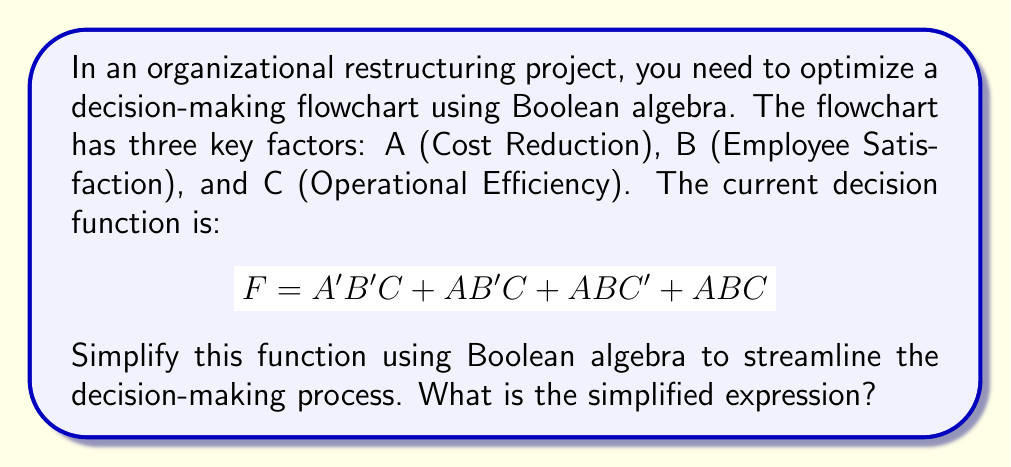Give your solution to this math problem. Let's simplify the given function step by step using Boolean algebra laws:

1) Start with the given function:
   $F = A'B'C + AB'C + ABC' + ABC$

2) Factor out B'C from the first two terms:
   $F = B'C(A' + A) + ABC' + ABC$

3) Simplify (A' + A) to 1 using the complement law:
   $F = B'C + ABC' + ABC$

4) Factor out AB from the last two terms:
   $F = B'C + AB(C' + C)$

5) Simplify (C' + C) to 1 using the complement law:
   $F = B'C + AB$

6) This expression cannot be simplified further.

The simplified function $F = B'C + AB$ means that the restructuring decision should be made when either:
- Cost reduction is not achieved, but operational efficiency is improved (B'C), or
- Cost reduction is achieved and employee satisfaction is maintained (AB).

This simplification reduces the number of terms from 4 to 2, making the decision-making process more efficient and easier to implement in the organizational restructuring project.
Answer: $F = B'C + AB$ 